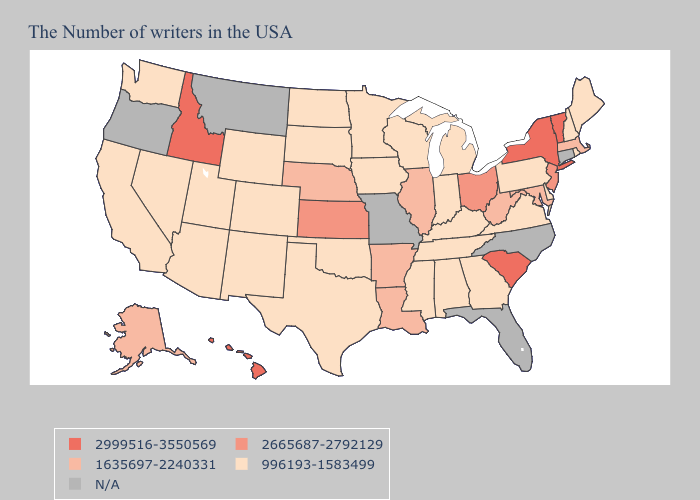Does Ohio have the lowest value in the USA?
Write a very short answer. No. Name the states that have a value in the range 1635697-2240331?
Short answer required. Massachusetts, Maryland, West Virginia, Illinois, Louisiana, Arkansas, Nebraska, Alaska. What is the highest value in the USA?
Be succinct. 2999516-3550569. What is the value of Vermont?
Short answer required. 2999516-3550569. Among the states that border Oregon , does Nevada have the highest value?
Write a very short answer. No. Which states hav the highest value in the West?
Keep it brief. Idaho, Hawaii. Among the states that border Vermont , which have the highest value?
Keep it brief. New York. What is the value of Washington?
Write a very short answer. 996193-1583499. What is the value of North Carolina?
Concise answer only. N/A. Does Illinois have the lowest value in the MidWest?
Concise answer only. No. 